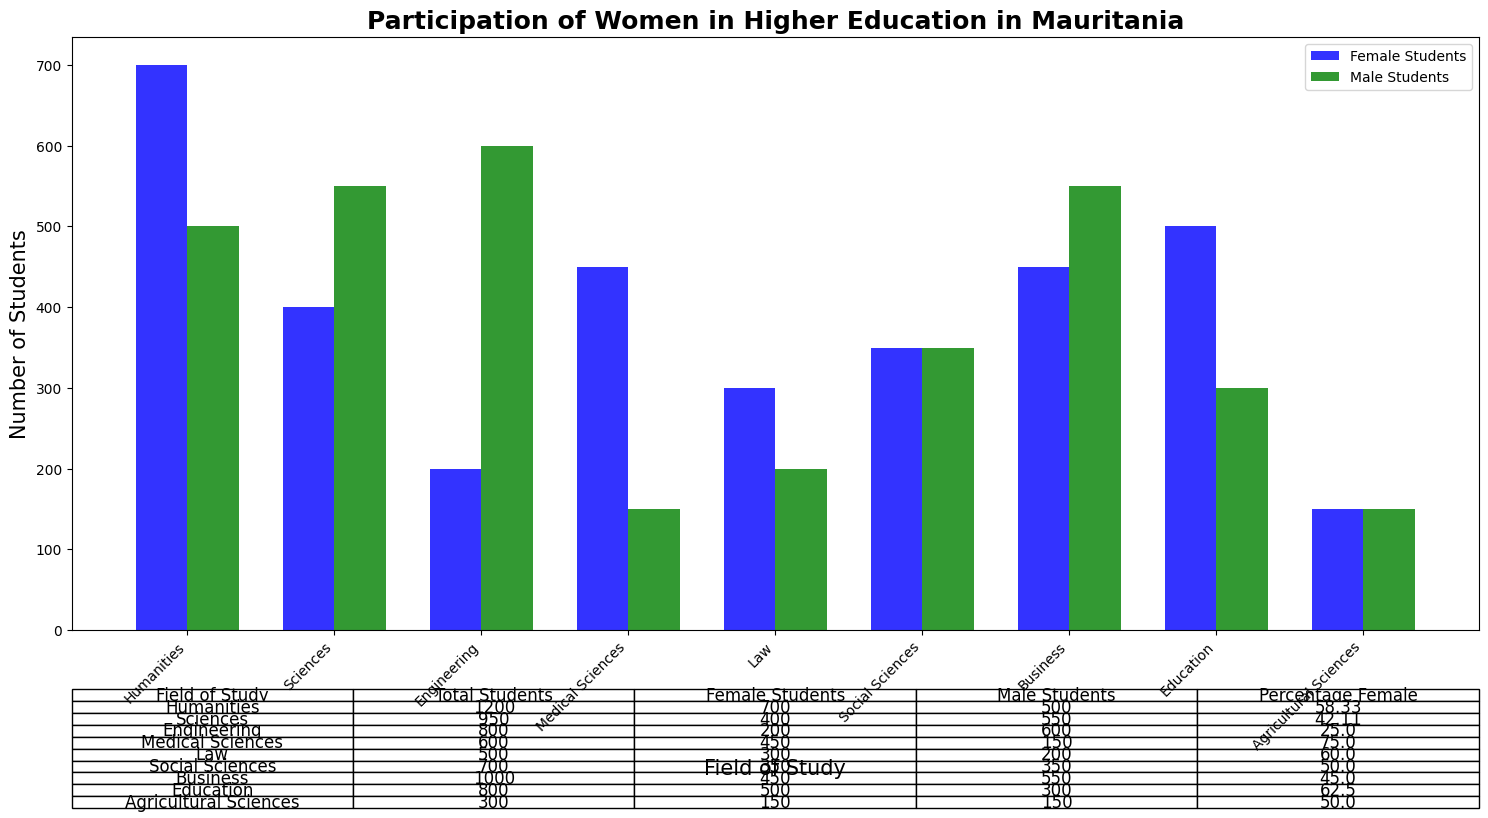What is the total number of female students in the Education field? To find the answer, you refer to the bar for female students in the Education field. The data shows that there are 500 female students in the Education field.
Answer: 500 Which field has the highest percentage of female students? By examining the "Percentage Female" column in the table below the bar plot, you can see that Medical Sciences has the highest percentage of female students at 75.00%.
Answer: Medical Sciences How many more male students are there than female students in the Engineering field? We find the number of male and female students in the Engineering field: 600 (male) and 200 (female). The difference is calculated as 600 - 200 = 400.
Answer: 400 In which field are male and female students equal in number? By checking the table below the bar plot, we find that the Agricultural Sciences field has an equal number of male and female students, both at 150.
Answer: Agricultural Sciences What is the total number of students in the Humanities and Medical Sciences fields combined? We add the total number of students in both fields: Humanities (1200) + Medical Sciences (600). Therefore, the combined total is 1200 + 600 = 1800.
Answer: 1800 What proportion of the total students in the Social Sciences are female? The number of female students in Social Sciences is 350, and the total students in Social Sciences are 700. The proportion is calculated as 350 / 700 = 0.50 or 50%.
Answer: 50% How does the number of female students in Business compare to Engineering? According to the visual information, Business has 450 female students while Engineering has 200 female students. Therefore, there are 450 - 200 = 250 more female students in Business compared to Engineering.
Answer: 250 more in Business Which field has the largest difference between the number of male and female students? The largest difference can be determined by subtracting the number of female students from male students for each field, then finding the maximum difference. Engineering has a difference of 600 - 200 = 400, which is the largest among all fields.
Answer: Engineering Is there any field where the number of male students is less than the number of female students? If so, name one such field. By comparing the bars of male and female students in the graph, we can see that in the Humanities, Medical Sciences, Law, and Education fields, the number of male students is less than the number of female students. One of these fields is Medical Sciences.
Answer: Medical Sciences Which field has a nearly equal ratio of male to female students? From the table, we can observe that Agricultural Sciences has an equal number of male and female students, which provides a nearly equal ratio of 1:1.
Answer: Agricultural Sciences 